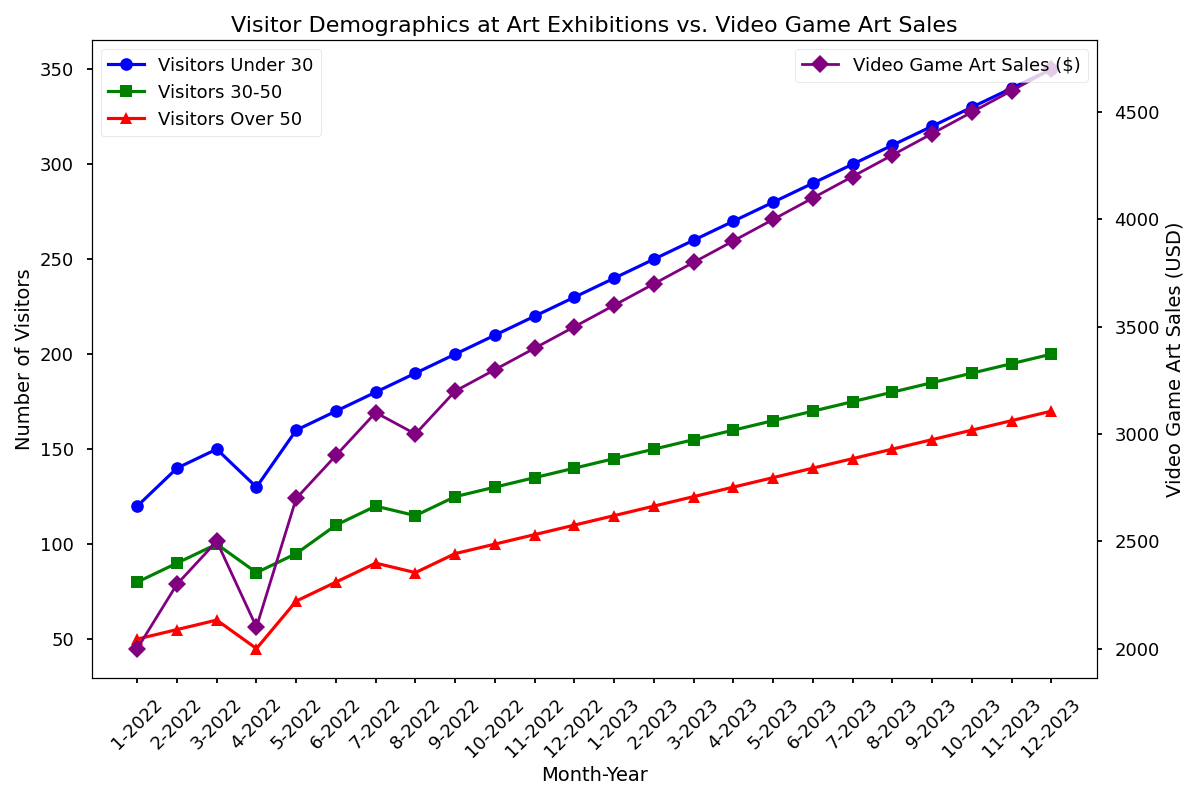What is the difference between the number of Visitors Under 30 and Visitors Over 50 in January 2022? Looking at January 2022, the number of Visitors Under 30 is 120 and the number of Visitors Over 50 is 50. The difference is calculated as 120 - 50.
Answer: 70 Which age group saw the most significant increase in visitor numbers from January 2022 to December 2023? By examining the data, we see that Visitors Under 30 increased from 120 in January 2022 to 350 in December 2023, Visitors 30-50 from 80 to 200, and Visitors Over 50 from 50 to 170. The Visitors Under 30 category shows the largest increase.
Answer: Visitors Under 30 Which month had the highest Video Game Art Sales? Observing the secondary y-axis for Video Game Art Sales, it peaks in December 2023 at 4700 USD.
Answer: December 2023 How does the trend in Visitors Under 30 correlate with Video Game Art Sales? Both curves (Visitors Under 30 and Video Game Art Sales) show a generally upward trend over time, suggesting a possible positive correlation between younger visitors and sales of video game-themed art.
Answer: Positive correlation By how much did Video Game Art Sales increase from June 2022 to June 2023? Video Game Art Sales were 2900 USD in June 2022 and 4100 USD in June 2023. The increase is 4100 - 2900.
Answer: 1200 USD What is the sum of Visitors 30-50 and Visitors Over 50 in March 2023? In March 2023, Visitors 30-50 are 155 and Visitors Over 50 are 125. Their sum is 155 + 125.
Answer: 280 Is there any month where all visitor groups (Under 30, 30-50, Over 50) have the same numbers? Observing the plot, there is no month where the number of Visitors Under 30, Visitors 30-50, and Visitors Over 50 are identical.
Answer: No Are the numbers of Visitors Over 50 ever higher than those of Visitors 30-50? Throughout the figure, the numbers of Visitors Over 50 are consistently lower than those of Visitors 30-50.
Answer: No Which months show the highest diversity in visitor age groups, and what does it imply? The months with a higher disparity between the three visitor age groups, such as January 2023 (240 Under 30, 145 30-50, 115 Over 50) and December 2023, show more diversity, indicating varied preferences and engagement among different age groups.
Answer: January 2023, December 2023 (diverse preferences) 